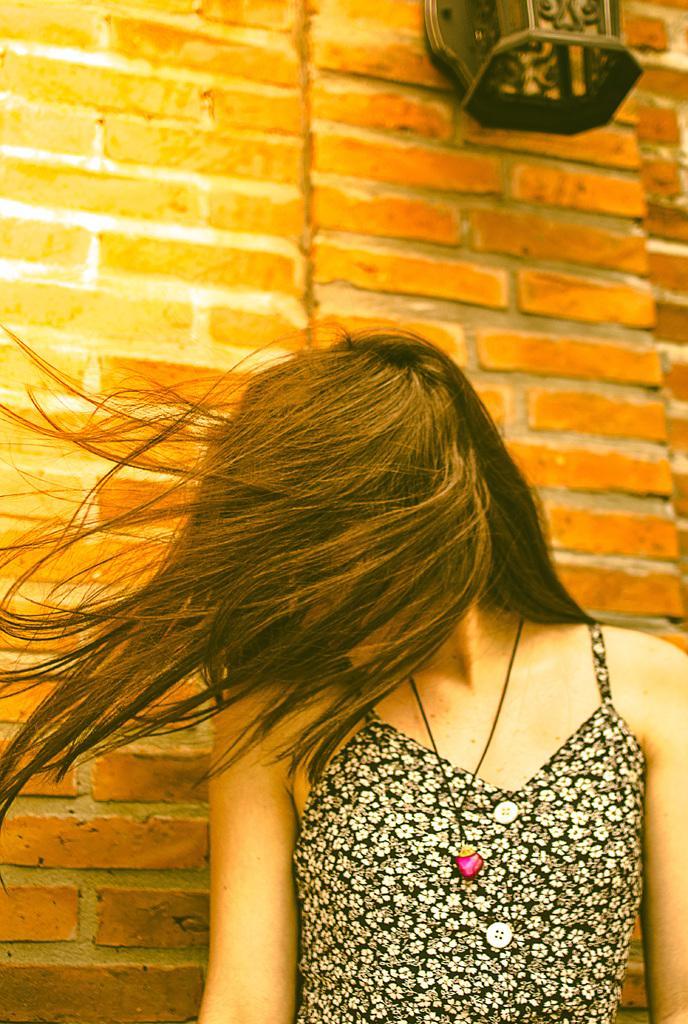Could you give a brief overview of what you see in this image? Here we can see a woman and her face is covered with her hair. In the background we can see an object on the wall. 